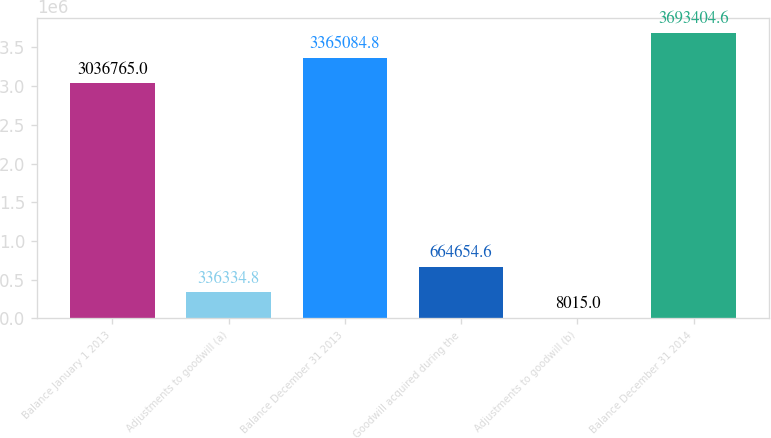Convert chart to OTSL. <chart><loc_0><loc_0><loc_500><loc_500><bar_chart><fcel>Balance January 1 2013<fcel>Adjustments to goodwill (a)<fcel>Balance December 31 2013<fcel>Goodwill acquired during the<fcel>Adjustments to goodwill (b)<fcel>Balance December 31 2014<nl><fcel>3.03676e+06<fcel>336335<fcel>3.36508e+06<fcel>664655<fcel>8015<fcel>3.6934e+06<nl></chart> 